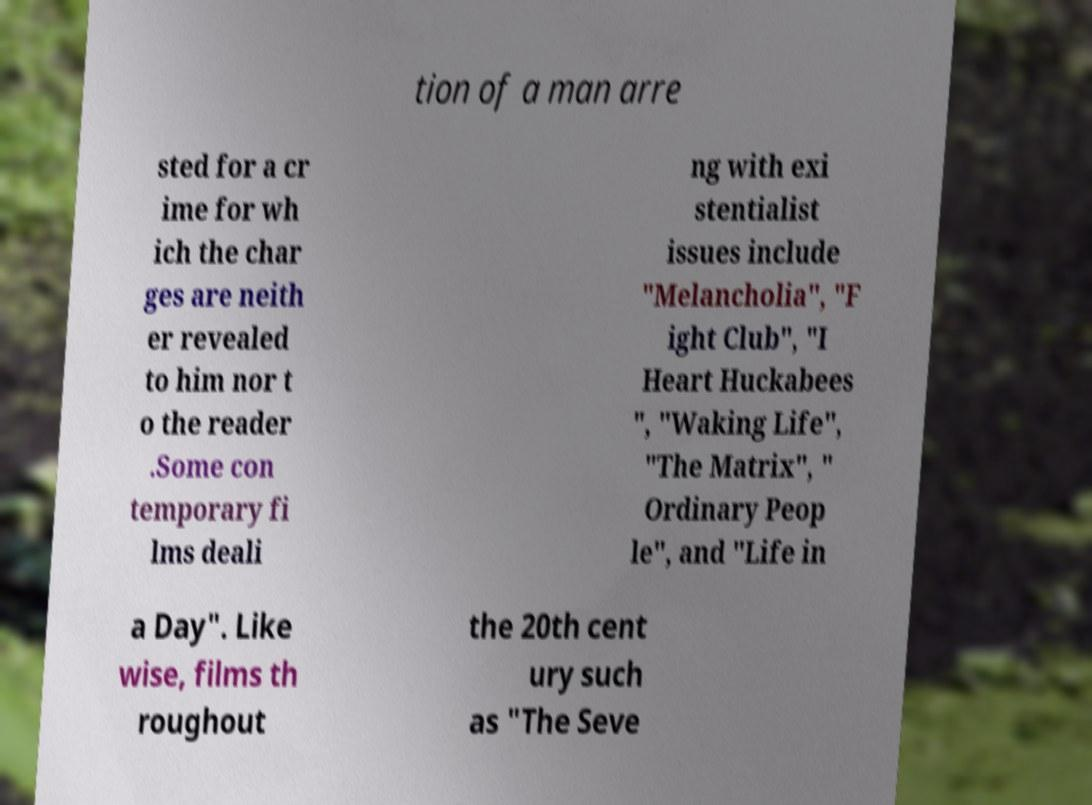Could you assist in decoding the text presented in this image and type it out clearly? tion of a man arre sted for a cr ime for wh ich the char ges are neith er revealed to him nor t o the reader .Some con temporary fi lms deali ng with exi stentialist issues include "Melancholia", "F ight Club", "I Heart Huckabees ", "Waking Life", "The Matrix", " Ordinary Peop le", and "Life in a Day". Like wise, films th roughout the 20th cent ury such as "The Seve 